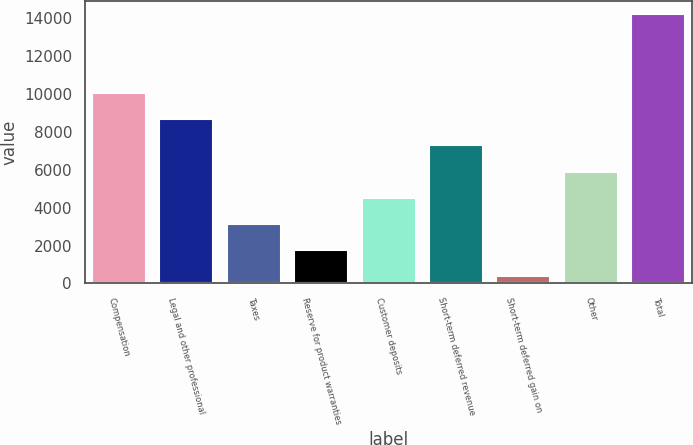<chart> <loc_0><loc_0><loc_500><loc_500><bar_chart><fcel>Compensation<fcel>Legal and other professional<fcel>Taxes<fcel>Reserve for product warranties<fcel>Customer deposits<fcel>Short-term deferred revenue<fcel>Short-term deferred gain on<fcel>Other<fcel>Total<nl><fcel>10059.5<fcel>8676<fcel>3142<fcel>1758.5<fcel>4525.5<fcel>7292.5<fcel>375<fcel>5909<fcel>14210<nl></chart> 